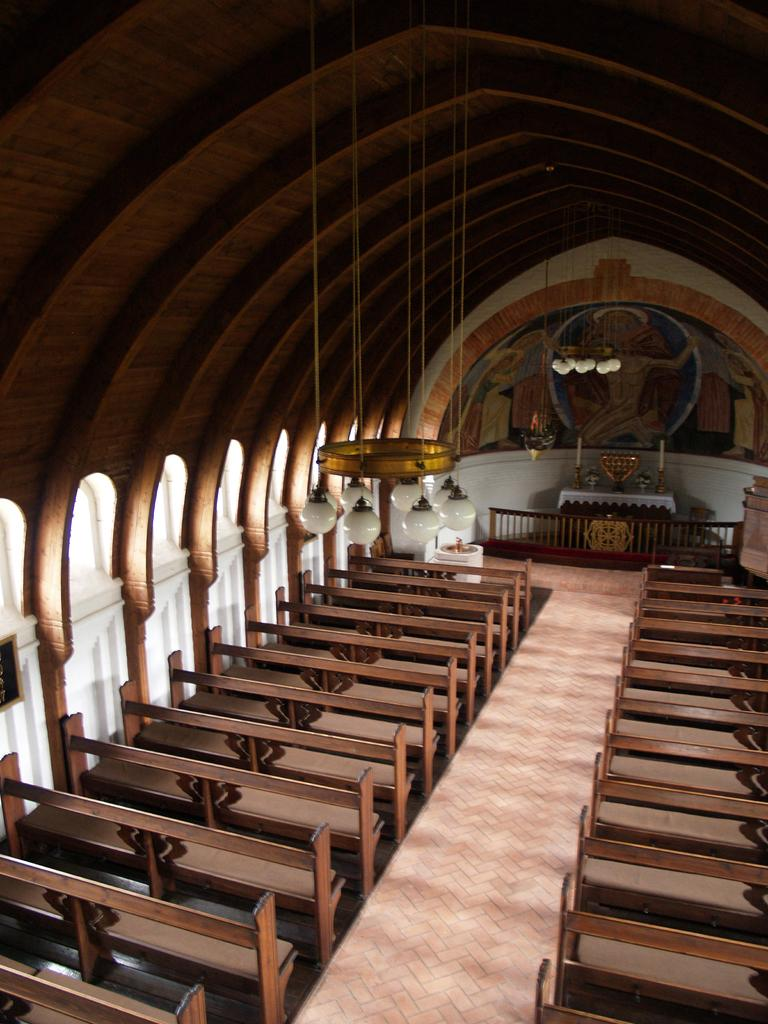What is the main feature of the image? There is an aisle in the image. What is located on both sides of the aisle? There are benches on both sides of the aisle. What can be seen above the aisle? The ceiling is visible in the image. What type of lighting is present in the image? There are chandeliers in the image. What is used for support or guidance in the image? There is a railing in the image. What type of furniture is present in the image? There is a table in the image. What type of decorations are on the walls in the image? There are paintings on the wall in the image. What grade of birds can be seen flying in the image? There are no birds present in the image. How are the paintings on the wall sorted in the image? The paintings on the wall are not sorted in any particular way in the image. 